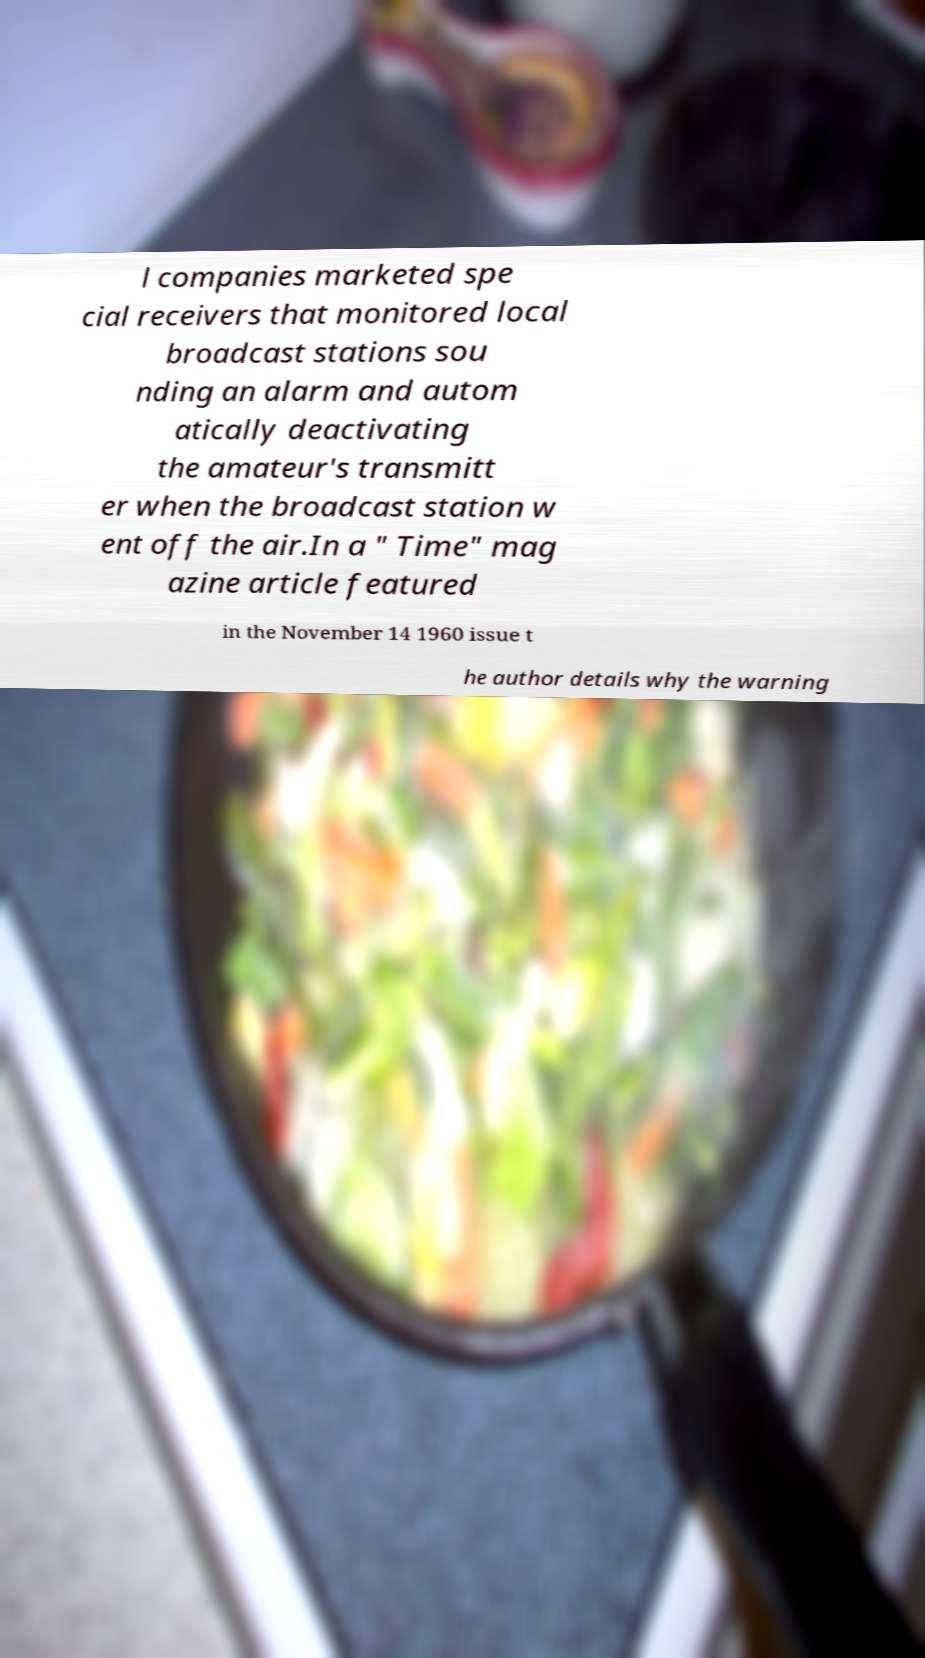Could you extract and type out the text from this image? l companies marketed spe cial receivers that monitored local broadcast stations sou nding an alarm and autom atically deactivating the amateur's transmitt er when the broadcast station w ent off the air.In a " Time" mag azine article featured in the November 14 1960 issue t he author details why the warning 